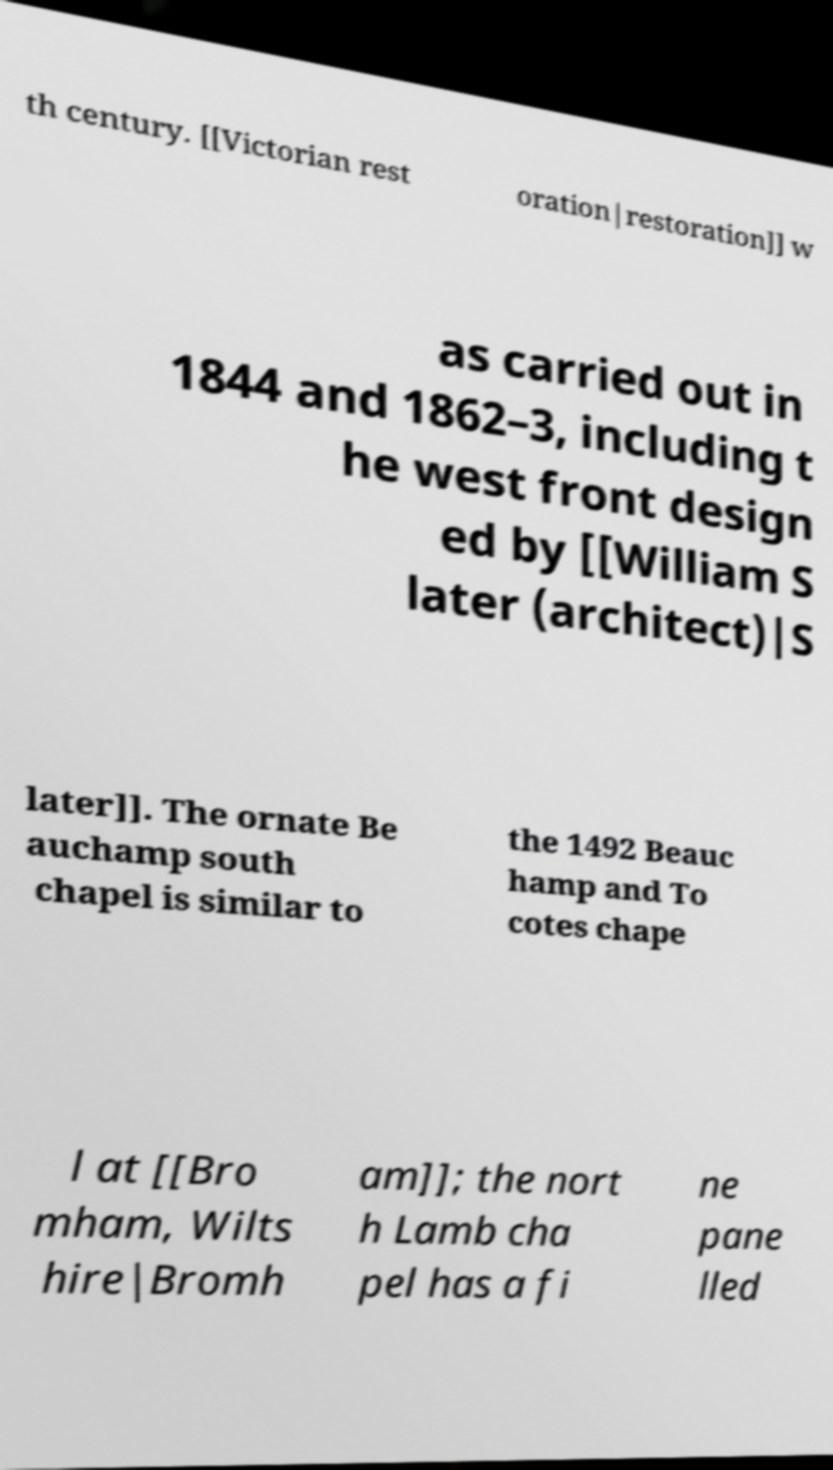Please identify and transcribe the text found in this image. th century. [[Victorian rest oration|restoration]] w as carried out in 1844 and 1862–3, including t he west front design ed by [[William S later (architect)|S later]]. The ornate Be auchamp south chapel is similar to the 1492 Beauc hamp and To cotes chape l at [[Bro mham, Wilts hire|Bromh am]]; the nort h Lamb cha pel has a fi ne pane lled 